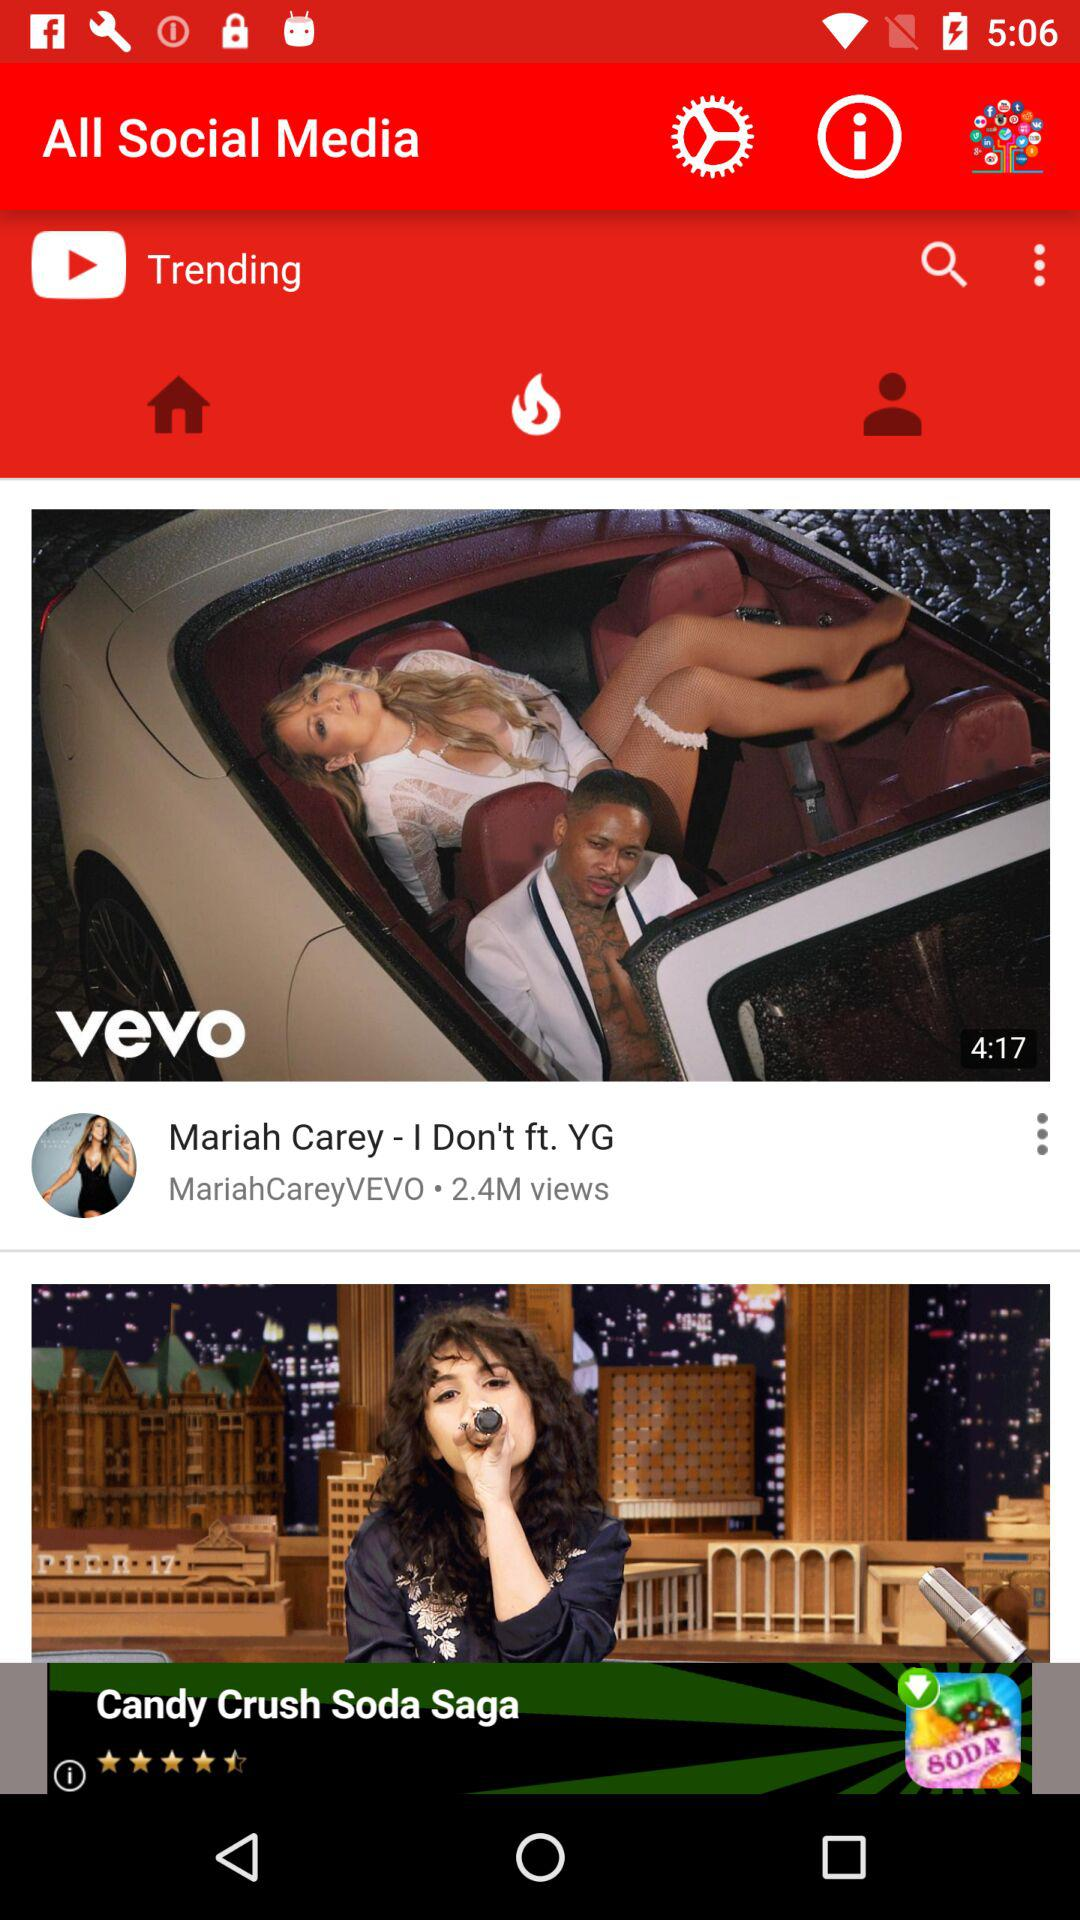What is the number of views on "Mariah Carey - I Don't ft. YG" video? The number of views on "Mariah Carey - I Don't ft. YG" video is 2.4 million. 